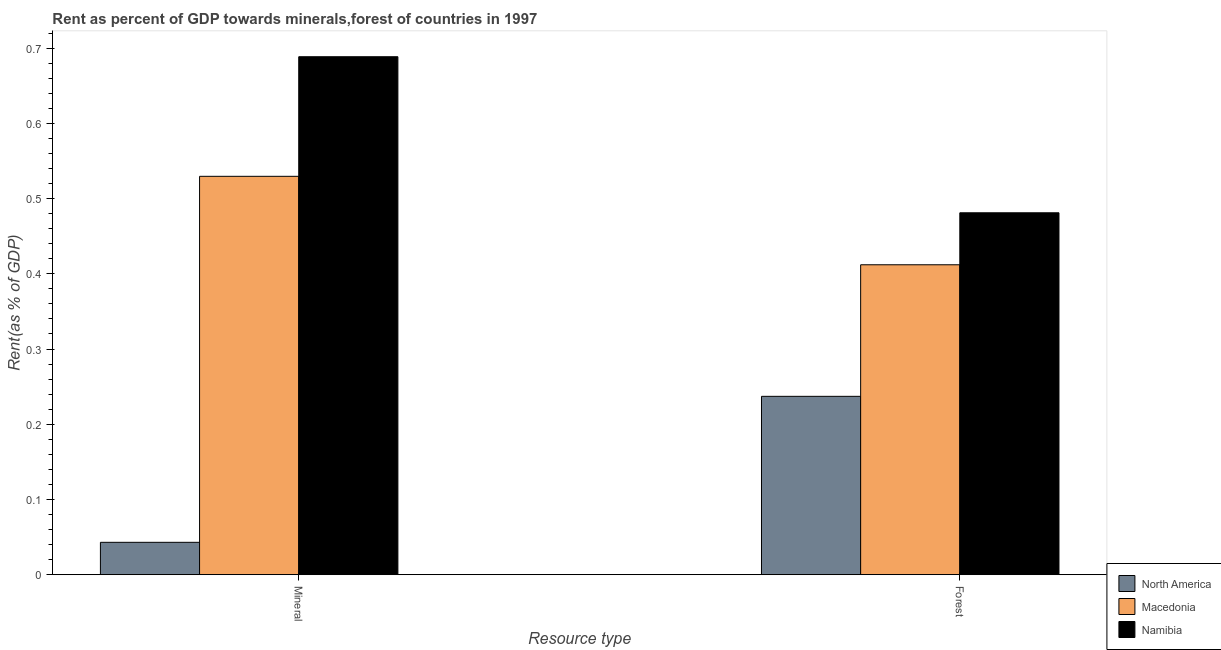How many bars are there on the 1st tick from the left?
Make the answer very short. 3. What is the label of the 2nd group of bars from the left?
Ensure brevity in your answer.  Forest. What is the forest rent in North America?
Give a very brief answer. 0.24. Across all countries, what is the maximum forest rent?
Your answer should be very brief. 0.48. Across all countries, what is the minimum forest rent?
Your response must be concise. 0.24. In which country was the mineral rent maximum?
Ensure brevity in your answer.  Namibia. In which country was the forest rent minimum?
Ensure brevity in your answer.  North America. What is the total forest rent in the graph?
Provide a succinct answer. 1.13. What is the difference between the mineral rent in Macedonia and that in Namibia?
Offer a terse response. -0.16. What is the difference between the forest rent in Namibia and the mineral rent in North America?
Make the answer very short. 0.44. What is the average mineral rent per country?
Ensure brevity in your answer.  0.42. What is the difference between the forest rent and mineral rent in Macedonia?
Your answer should be very brief. -0.12. What is the ratio of the mineral rent in Namibia to that in Macedonia?
Keep it short and to the point. 1.3. Is the forest rent in Macedonia less than that in Namibia?
Ensure brevity in your answer.  Yes. In how many countries, is the mineral rent greater than the average mineral rent taken over all countries?
Your answer should be compact. 2. What does the 3rd bar from the left in Forest represents?
Provide a short and direct response. Namibia. What does the 2nd bar from the right in Forest represents?
Your answer should be very brief. Macedonia. How many bars are there?
Offer a terse response. 6. Are all the bars in the graph horizontal?
Provide a short and direct response. No. What is the difference between two consecutive major ticks on the Y-axis?
Your answer should be very brief. 0.1. Does the graph contain any zero values?
Your response must be concise. No. How many legend labels are there?
Offer a very short reply. 3. How are the legend labels stacked?
Ensure brevity in your answer.  Vertical. What is the title of the graph?
Offer a terse response. Rent as percent of GDP towards minerals,forest of countries in 1997. What is the label or title of the X-axis?
Your answer should be very brief. Resource type. What is the label or title of the Y-axis?
Make the answer very short. Rent(as % of GDP). What is the Rent(as % of GDP) of North America in Mineral?
Your answer should be compact. 0.04. What is the Rent(as % of GDP) of Macedonia in Mineral?
Ensure brevity in your answer.  0.53. What is the Rent(as % of GDP) of Namibia in Mineral?
Ensure brevity in your answer.  0.69. What is the Rent(as % of GDP) of North America in Forest?
Ensure brevity in your answer.  0.24. What is the Rent(as % of GDP) in Macedonia in Forest?
Make the answer very short. 0.41. What is the Rent(as % of GDP) in Namibia in Forest?
Your response must be concise. 0.48. Across all Resource type, what is the maximum Rent(as % of GDP) of North America?
Offer a terse response. 0.24. Across all Resource type, what is the maximum Rent(as % of GDP) of Macedonia?
Keep it short and to the point. 0.53. Across all Resource type, what is the maximum Rent(as % of GDP) of Namibia?
Keep it short and to the point. 0.69. Across all Resource type, what is the minimum Rent(as % of GDP) of North America?
Offer a terse response. 0.04. Across all Resource type, what is the minimum Rent(as % of GDP) in Macedonia?
Ensure brevity in your answer.  0.41. Across all Resource type, what is the minimum Rent(as % of GDP) in Namibia?
Make the answer very short. 0.48. What is the total Rent(as % of GDP) in North America in the graph?
Provide a short and direct response. 0.28. What is the total Rent(as % of GDP) of Macedonia in the graph?
Your answer should be compact. 0.94. What is the total Rent(as % of GDP) of Namibia in the graph?
Keep it short and to the point. 1.17. What is the difference between the Rent(as % of GDP) of North America in Mineral and that in Forest?
Give a very brief answer. -0.19. What is the difference between the Rent(as % of GDP) in Macedonia in Mineral and that in Forest?
Your answer should be compact. 0.12. What is the difference between the Rent(as % of GDP) in Namibia in Mineral and that in Forest?
Offer a terse response. 0.21. What is the difference between the Rent(as % of GDP) in North America in Mineral and the Rent(as % of GDP) in Macedonia in Forest?
Keep it short and to the point. -0.37. What is the difference between the Rent(as % of GDP) of North America in Mineral and the Rent(as % of GDP) of Namibia in Forest?
Offer a very short reply. -0.44. What is the difference between the Rent(as % of GDP) in Macedonia in Mineral and the Rent(as % of GDP) in Namibia in Forest?
Offer a very short reply. 0.05. What is the average Rent(as % of GDP) of North America per Resource type?
Your answer should be very brief. 0.14. What is the average Rent(as % of GDP) of Macedonia per Resource type?
Your answer should be very brief. 0.47. What is the average Rent(as % of GDP) of Namibia per Resource type?
Your response must be concise. 0.58. What is the difference between the Rent(as % of GDP) in North America and Rent(as % of GDP) in Macedonia in Mineral?
Ensure brevity in your answer.  -0.49. What is the difference between the Rent(as % of GDP) of North America and Rent(as % of GDP) of Namibia in Mineral?
Your answer should be compact. -0.65. What is the difference between the Rent(as % of GDP) in Macedonia and Rent(as % of GDP) in Namibia in Mineral?
Offer a very short reply. -0.16. What is the difference between the Rent(as % of GDP) in North America and Rent(as % of GDP) in Macedonia in Forest?
Provide a succinct answer. -0.17. What is the difference between the Rent(as % of GDP) of North America and Rent(as % of GDP) of Namibia in Forest?
Your response must be concise. -0.24. What is the difference between the Rent(as % of GDP) of Macedonia and Rent(as % of GDP) of Namibia in Forest?
Make the answer very short. -0.07. What is the ratio of the Rent(as % of GDP) in North America in Mineral to that in Forest?
Your answer should be very brief. 0.18. What is the ratio of the Rent(as % of GDP) of Macedonia in Mineral to that in Forest?
Provide a succinct answer. 1.29. What is the ratio of the Rent(as % of GDP) of Namibia in Mineral to that in Forest?
Give a very brief answer. 1.43. What is the difference between the highest and the second highest Rent(as % of GDP) of North America?
Make the answer very short. 0.19. What is the difference between the highest and the second highest Rent(as % of GDP) of Macedonia?
Your answer should be very brief. 0.12. What is the difference between the highest and the second highest Rent(as % of GDP) of Namibia?
Your answer should be very brief. 0.21. What is the difference between the highest and the lowest Rent(as % of GDP) of North America?
Keep it short and to the point. 0.19. What is the difference between the highest and the lowest Rent(as % of GDP) in Macedonia?
Provide a short and direct response. 0.12. What is the difference between the highest and the lowest Rent(as % of GDP) of Namibia?
Offer a terse response. 0.21. 